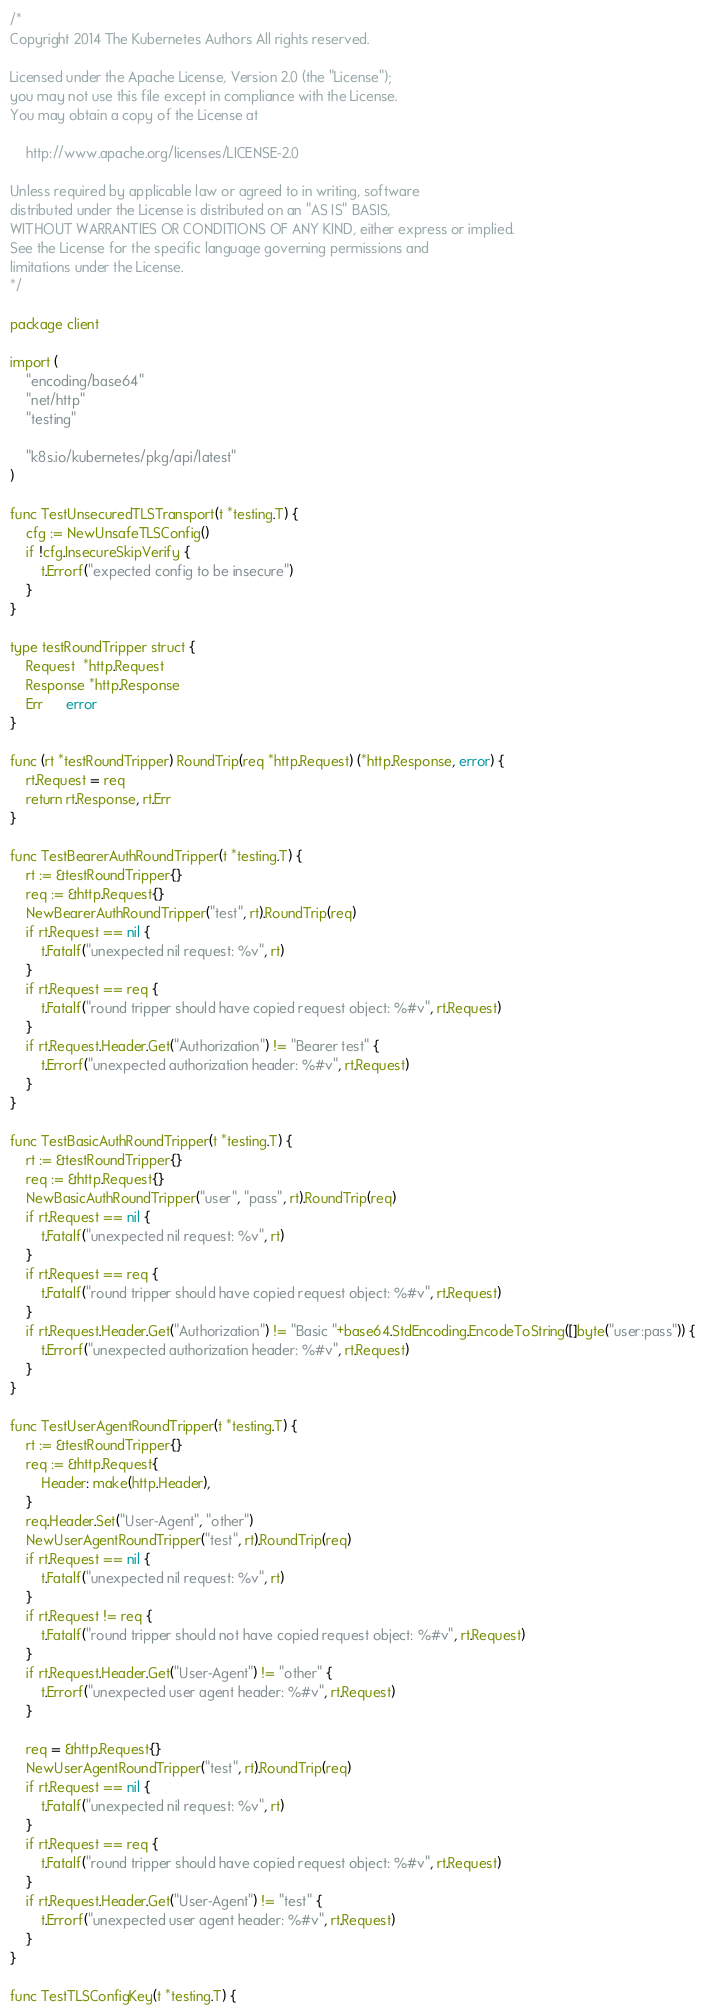<code> <loc_0><loc_0><loc_500><loc_500><_Go_>/*
Copyright 2014 The Kubernetes Authors All rights reserved.

Licensed under the Apache License, Version 2.0 (the "License");
you may not use this file except in compliance with the License.
You may obtain a copy of the License at

    http://www.apache.org/licenses/LICENSE-2.0

Unless required by applicable law or agreed to in writing, software
distributed under the License is distributed on an "AS IS" BASIS,
WITHOUT WARRANTIES OR CONDITIONS OF ANY KIND, either express or implied.
See the License for the specific language governing permissions and
limitations under the License.
*/

package client

import (
	"encoding/base64"
	"net/http"
	"testing"

	"k8s.io/kubernetes/pkg/api/latest"
)

func TestUnsecuredTLSTransport(t *testing.T) {
	cfg := NewUnsafeTLSConfig()
	if !cfg.InsecureSkipVerify {
		t.Errorf("expected config to be insecure")
	}
}

type testRoundTripper struct {
	Request  *http.Request
	Response *http.Response
	Err      error
}

func (rt *testRoundTripper) RoundTrip(req *http.Request) (*http.Response, error) {
	rt.Request = req
	return rt.Response, rt.Err
}

func TestBearerAuthRoundTripper(t *testing.T) {
	rt := &testRoundTripper{}
	req := &http.Request{}
	NewBearerAuthRoundTripper("test", rt).RoundTrip(req)
	if rt.Request == nil {
		t.Fatalf("unexpected nil request: %v", rt)
	}
	if rt.Request == req {
		t.Fatalf("round tripper should have copied request object: %#v", rt.Request)
	}
	if rt.Request.Header.Get("Authorization") != "Bearer test" {
		t.Errorf("unexpected authorization header: %#v", rt.Request)
	}
}

func TestBasicAuthRoundTripper(t *testing.T) {
	rt := &testRoundTripper{}
	req := &http.Request{}
	NewBasicAuthRoundTripper("user", "pass", rt).RoundTrip(req)
	if rt.Request == nil {
		t.Fatalf("unexpected nil request: %v", rt)
	}
	if rt.Request == req {
		t.Fatalf("round tripper should have copied request object: %#v", rt.Request)
	}
	if rt.Request.Header.Get("Authorization") != "Basic "+base64.StdEncoding.EncodeToString([]byte("user:pass")) {
		t.Errorf("unexpected authorization header: %#v", rt.Request)
	}
}

func TestUserAgentRoundTripper(t *testing.T) {
	rt := &testRoundTripper{}
	req := &http.Request{
		Header: make(http.Header),
	}
	req.Header.Set("User-Agent", "other")
	NewUserAgentRoundTripper("test", rt).RoundTrip(req)
	if rt.Request == nil {
		t.Fatalf("unexpected nil request: %v", rt)
	}
	if rt.Request != req {
		t.Fatalf("round tripper should not have copied request object: %#v", rt.Request)
	}
	if rt.Request.Header.Get("User-Agent") != "other" {
		t.Errorf("unexpected user agent header: %#v", rt.Request)
	}

	req = &http.Request{}
	NewUserAgentRoundTripper("test", rt).RoundTrip(req)
	if rt.Request == nil {
		t.Fatalf("unexpected nil request: %v", rt)
	}
	if rt.Request == req {
		t.Fatalf("round tripper should have copied request object: %#v", rt.Request)
	}
	if rt.Request.Header.Get("User-Agent") != "test" {
		t.Errorf("unexpected user agent header: %#v", rt.Request)
	}
}

func TestTLSConfigKey(t *testing.T) {</code> 